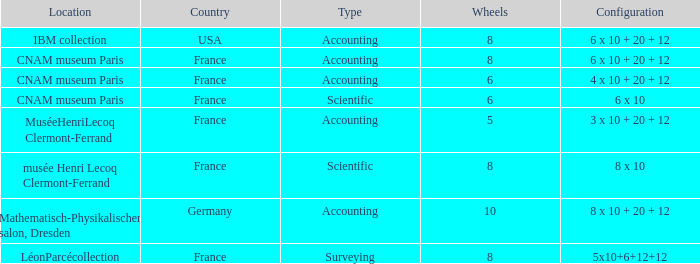What location has surveying as the type? LéonParcécollection. 